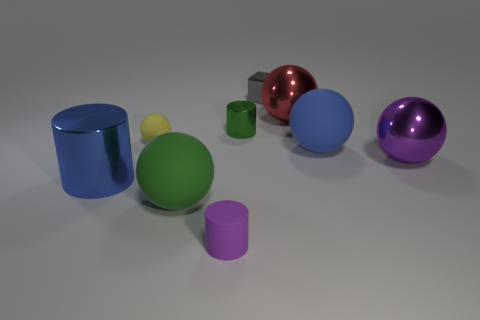Subtract 2 balls. How many balls are left? 3 Subtract all purple spheres. How many spheres are left? 4 Subtract all green balls. How many balls are left? 4 Subtract all cyan spheres. Subtract all yellow cylinders. How many spheres are left? 5 Subtract all balls. How many objects are left? 4 Add 5 tiny brown cubes. How many tiny brown cubes exist? 5 Subtract 1 blue spheres. How many objects are left? 8 Subtract all purple metallic balls. Subtract all small rubber cylinders. How many objects are left? 7 Add 9 purple rubber things. How many purple rubber things are left? 10 